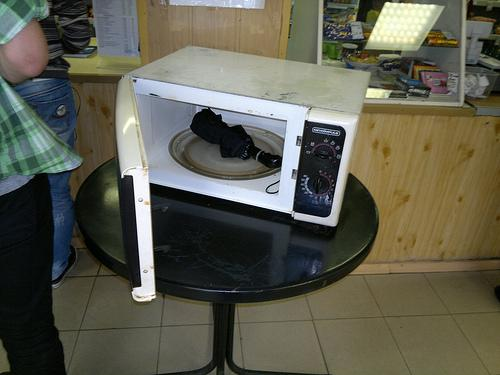Explain the most conspicuous element in the image and what it implies. The most conspicuous element is an old microwave with an umbrella in it, implying an unexpected or unusual situation. Write a concise statement describing the central focus of the image. The central focus is an old microwave containing an umbrella, placed on a black wooden table in a room with people wearing plaid shirts. Describe the main object in the image and how it contrasts with other objects. An old white microwave with a black umbrella in it stands out from the black table, glass display case, and individuals in plaid shirts in the background. Write a sentence focusing on the primary object in the image and the setting in which it is placed. The primary object is an old white microwave with an umbrella in it, situated on a black wooden table in a room with a tiled floor and a glass display case. Provide a brief overview of the focal point in the image. An old white microwave with an open door and a black umbrella inside it is placed on a black wooden table. Identify the key object in the image and mention what makes it unusual. The key object is an umbrella inside a microwave, which is unusual since umbrellas are not typically found in microwaves. Write a simple sentence explaining the primary object and its surroundings in the image. The image shows an umbrella inside an old white microwave sitting on a black table, surrounded by a glass display case and individuals wearing plaid shirts. In one sentence, describe the main object in the image and mention two other noticeable elements. The main object is an old microwave with an umbrella inside, placed on a black table, with a glass display case and people wearing plaid shirts also in the scene. Describe the scene in the image, focusing on the most interesting object. An old microwave on a table has a black umbrella placed inside it, with other objects like a glass display case and people in plaid shirts in the background. Summarize the core subject of the image in a brief statement. The core subject is an old microwave with an umbrella inside, presented in a room with people wearing plaid shirts and a glass display case. 